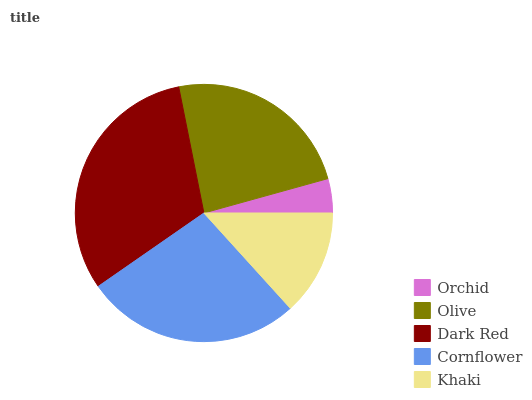Is Orchid the minimum?
Answer yes or no. Yes. Is Dark Red the maximum?
Answer yes or no. Yes. Is Olive the minimum?
Answer yes or no. No. Is Olive the maximum?
Answer yes or no. No. Is Olive greater than Orchid?
Answer yes or no. Yes. Is Orchid less than Olive?
Answer yes or no. Yes. Is Orchid greater than Olive?
Answer yes or no. No. Is Olive less than Orchid?
Answer yes or no. No. Is Olive the high median?
Answer yes or no. Yes. Is Olive the low median?
Answer yes or no. Yes. Is Dark Red the high median?
Answer yes or no. No. Is Khaki the low median?
Answer yes or no. No. 